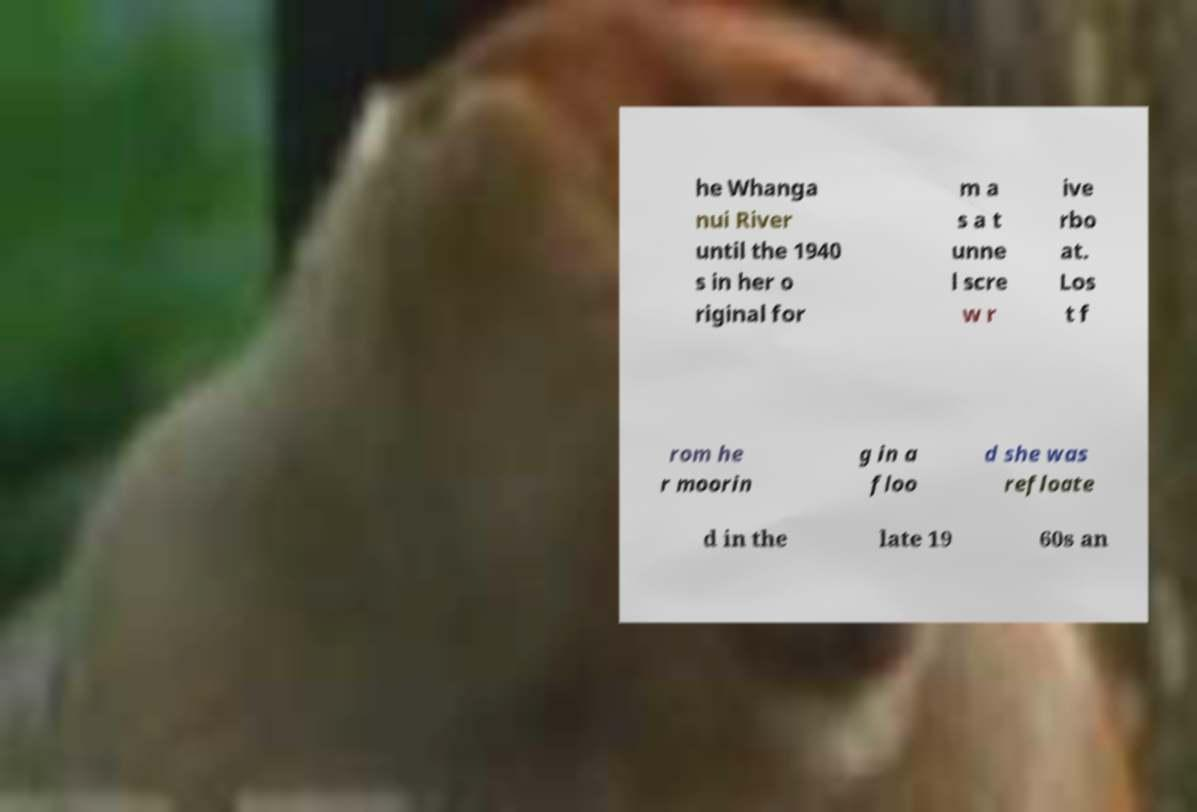What messages or text are displayed in this image? I need them in a readable, typed format. he Whanga nui River until the 1940 s in her o riginal for m a s a t unne l scre w r ive rbo at. Los t f rom he r moorin g in a floo d she was refloate d in the late 19 60s an 